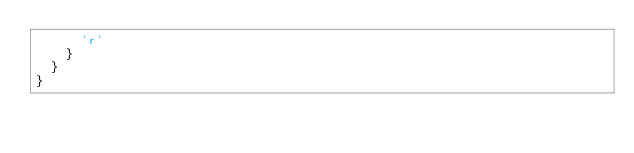Convert code to text. <code><loc_0><loc_0><loc_500><loc_500><_MoonScript_>      'r'
    }
  }
}
</code> 